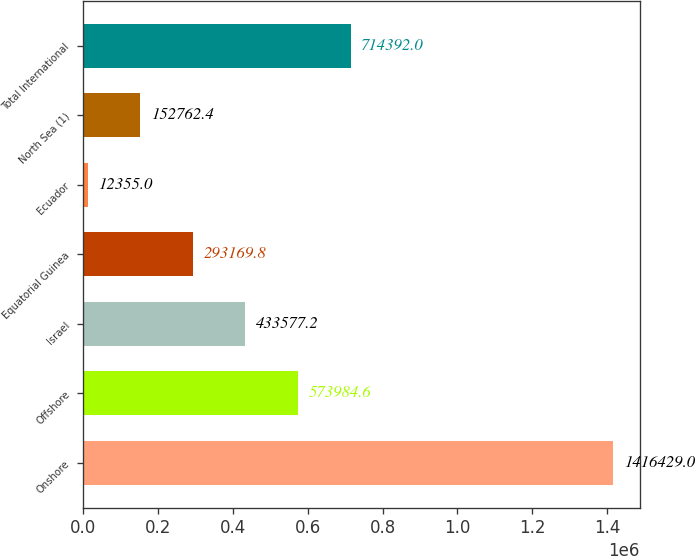Convert chart to OTSL. <chart><loc_0><loc_0><loc_500><loc_500><bar_chart><fcel>Onshore<fcel>Offshore<fcel>Israel<fcel>Equatorial Guinea<fcel>Ecuador<fcel>North Sea (1)<fcel>Total International<nl><fcel>1.41643e+06<fcel>573985<fcel>433577<fcel>293170<fcel>12355<fcel>152762<fcel>714392<nl></chart> 